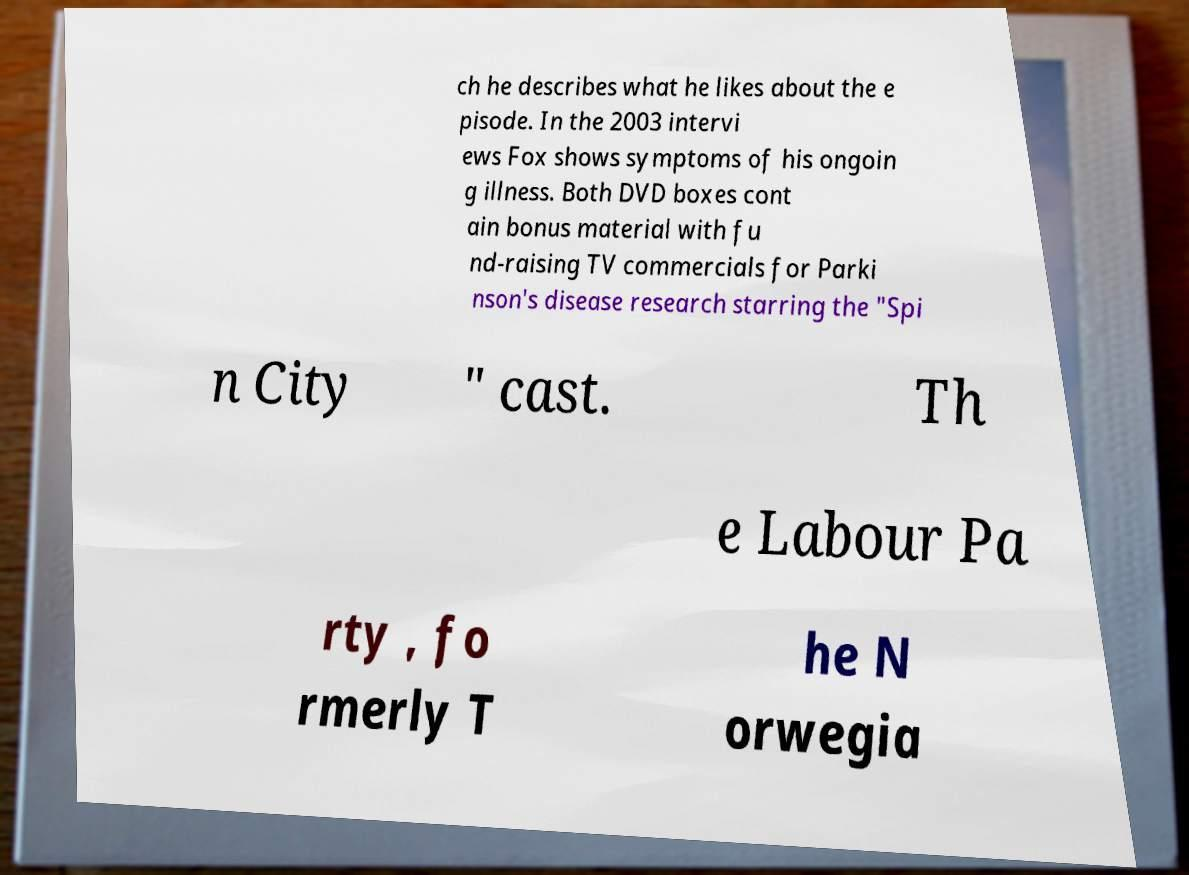I need the written content from this picture converted into text. Can you do that? ch he describes what he likes about the e pisode. In the 2003 intervi ews Fox shows symptoms of his ongoin g illness. Both DVD boxes cont ain bonus material with fu nd-raising TV commercials for Parki nson's disease research starring the "Spi n City " cast. Th e Labour Pa rty , fo rmerly T he N orwegia 